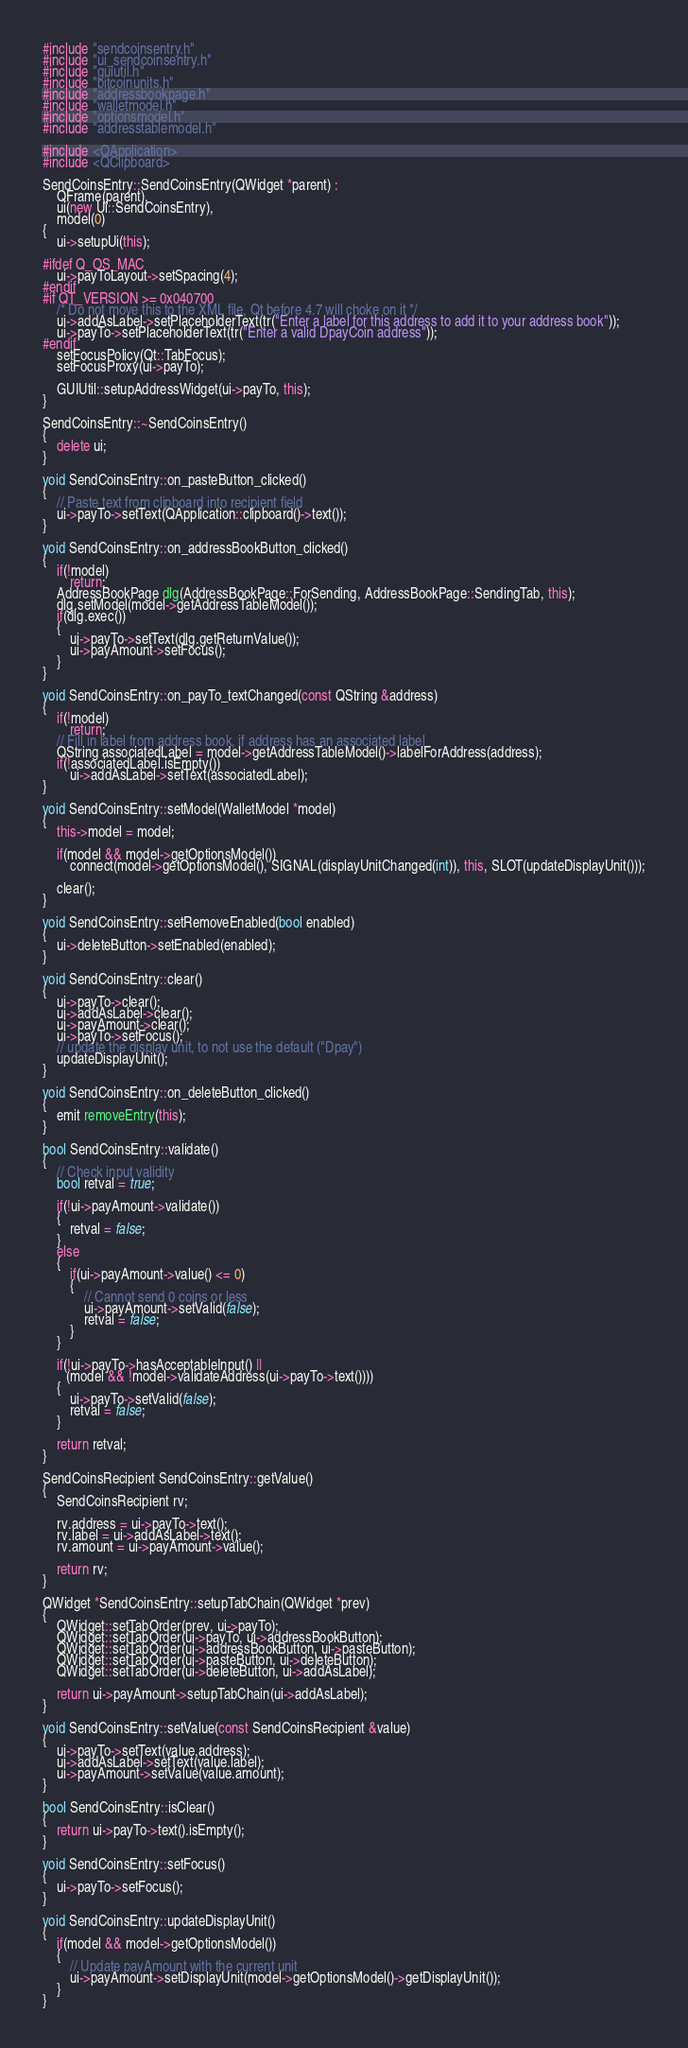Convert code to text. <code><loc_0><loc_0><loc_500><loc_500><_C++_>#include "sendcoinsentry.h"
#include "ui_sendcoinsentry.h"
#include "guiutil.h"
#include "bitcoinunits.h"
#include "addressbookpage.h"
#include "walletmodel.h"
#include "optionsmodel.h"
#include "addresstablemodel.h"

#include <QApplication>
#include <QClipboard>

SendCoinsEntry::SendCoinsEntry(QWidget *parent) :
    QFrame(parent),
    ui(new Ui::SendCoinsEntry),
    model(0)
{
    ui->setupUi(this);

#ifdef Q_OS_MAC
    ui->payToLayout->setSpacing(4);
#endif
#if QT_VERSION >= 0x040700
    /* Do not move this to the XML file, Qt before 4.7 will choke on it */
    ui->addAsLabel->setPlaceholderText(tr("Enter a label for this address to add it to your address book"));
    ui->payTo->setPlaceholderText(tr("Enter a valid DpayCoin address"));
#endif
    setFocusPolicy(Qt::TabFocus);
    setFocusProxy(ui->payTo);

    GUIUtil::setupAddressWidget(ui->payTo, this);
}

SendCoinsEntry::~SendCoinsEntry()
{
    delete ui;
}

void SendCoinsEntry::on_pasteButton_clicked()
{
    // Paste text from clipboard into recipient field
    ui->payTo->setText(QApplication::clipboard()->text());
}

void SendCoinsEntry::on_addressBookButton_clicked()
{
    if(!model)
        return;
    AddressBookPage dlg(AddressBookPage::ForSending, AddressBookPage::SendingTab, this);
    dlg.setModel(model->getAddressTableModel());
    if(dlg.exec())
    {
        ui->payTo->setText(dlg.getReturnValue());
        ui->payAmount->setFocus();
    }
}

void SendCoinsEntry::on_payTo_textChanged(const QString &address)
{
    if(!model)
        return;
    // Fill in label from address book, if address has an associated label
    QString associatedLabel = model->getAddressTableModel()->labelForAddress(address);
    if(!associatedLabel.isEmpty())
        ui->addAsLabel->setText(associatedLabel);
}

void SendCoinsEntry::setModel(WalletModel *model)
{
    this->model = model;

    if(model && model->getOptionsModel())
        connect(model->getOptionsModel(), SIGNAL(displayUnitChanged(int)), this, SLOT(updateDisplayUnit()));

    clear();
}

void SendCoinsEntry::setRemoveEnabled(bool enabled)
{
    ui->deleteButton->setEnabled(enabled);
}

void SendCoinsEntry::clear()
{
    ui->payTo->clear();
    ui->addAsLabel->clear();
    ui->payAmount->clear();
    ui->payTo->setFocus();
    // update the display unit, to not use the default ("Dpay")
    updateDisplayUnit();
}

void SendCoinsEntry::on_deleteButton_clicked()
{
    emit removeEntry(this);
}

bool SendCoinsEntry::validate()
{
    // Check input validity
    bool retval = true;

    if(!ui->payAmount->validate())
    {
        retval = false;
    }
    else
    {
        if(ui->payAmount->value() <= 0)
        {
            // Cannot send 0 coins or less
            ui->payAmount->setValid(false);
            retval = false;
        }
    }

    if(!ui->payTo->hasAcceptableInput() ||
       (model && !model->validateAddress(ui->payTo->text())))
    {
        ui->payTo->setValid(false);
        retval = false;
    }

    return retval;
}

SendCoinsRecipient SendCoinsEntry::getValue()
{
    SendCoinsRecipient rv;

    rv.address = ui->payTo->text();
    rv.label = ui->addAsLabel->text();
    rv.amount = ui->payAmount->value();

    return rv;
}

QWidget *SendCoinsEntry::setupTabChain(QWidget *prev)
{
	QWidget::setTabOrder(prev, ui->payTo);
    QWidget::setTabOrder(ui->payTo, ui->addressBookButton);
    QWidget::setTabOrder(ui->addressBookButton, ui->pasteButton);
    QWidget::setTabOrder(ui->pasteButton, ui->deleteButton);
    QWidget::setTabOrder(ui->deleteButton, ui->addAsLabel);

	return ui->payAmount->setupTabChain(ui->addAsLabel);
}

void SendCoinsEntry::setValue(const SendCoinsRecipient &value)
{
    ui->payTo->setText(value.address);
    ui->addAsLabel->setText(value.label);
    ui->payAmount->setValue(value.amount);
}

bool SendCoinsEntry::isClear()
{
    return ui->payTo->text().isEmpty();
}

void SendCoinsEntry::setFocus()
{
    ui->payTo->setFocus();
}

void SendCoinsEntry::updateDisplayUnit()
{
    if(model && model->getOptionsModel())
    {
        // Update payAmount with the current unit
        ui->payAmount->setDisplayUnit(model->getOptionsModel()->getDisplayUnit());
    }
}
</code> 